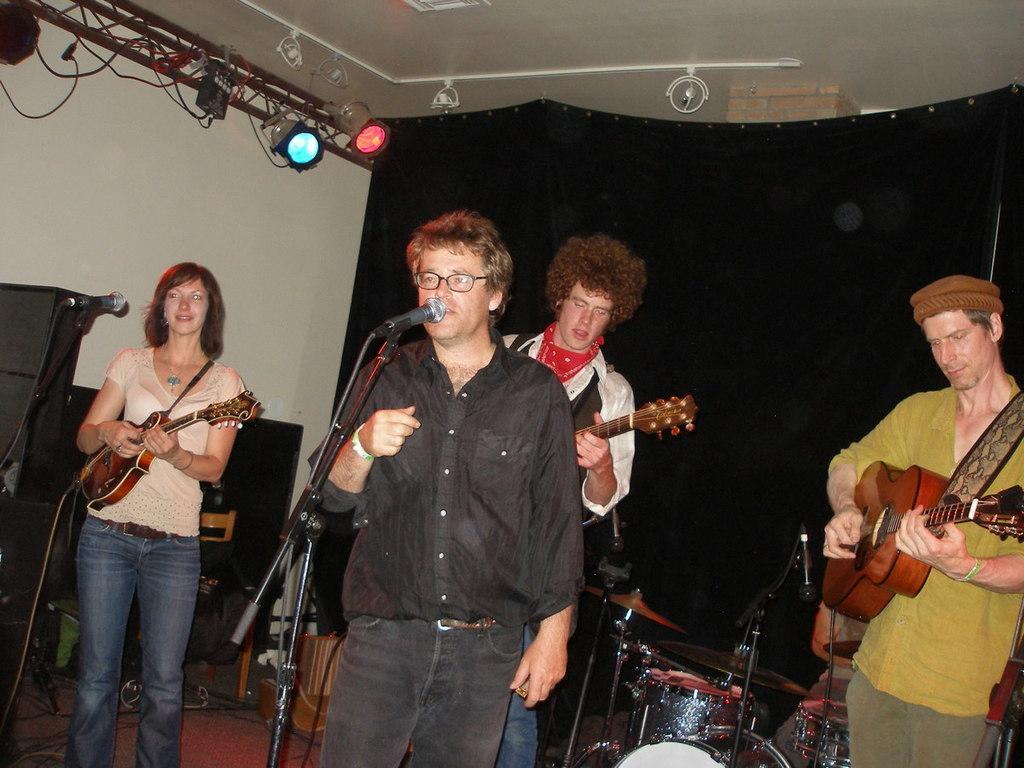Describe this image in one or two sentences. In this image, three people are playing a musical instrument. The center person is stand in-front of microphone ,he is singing. And background, we can see black cloth, wall, lights, rods, wires and here some boxes. 